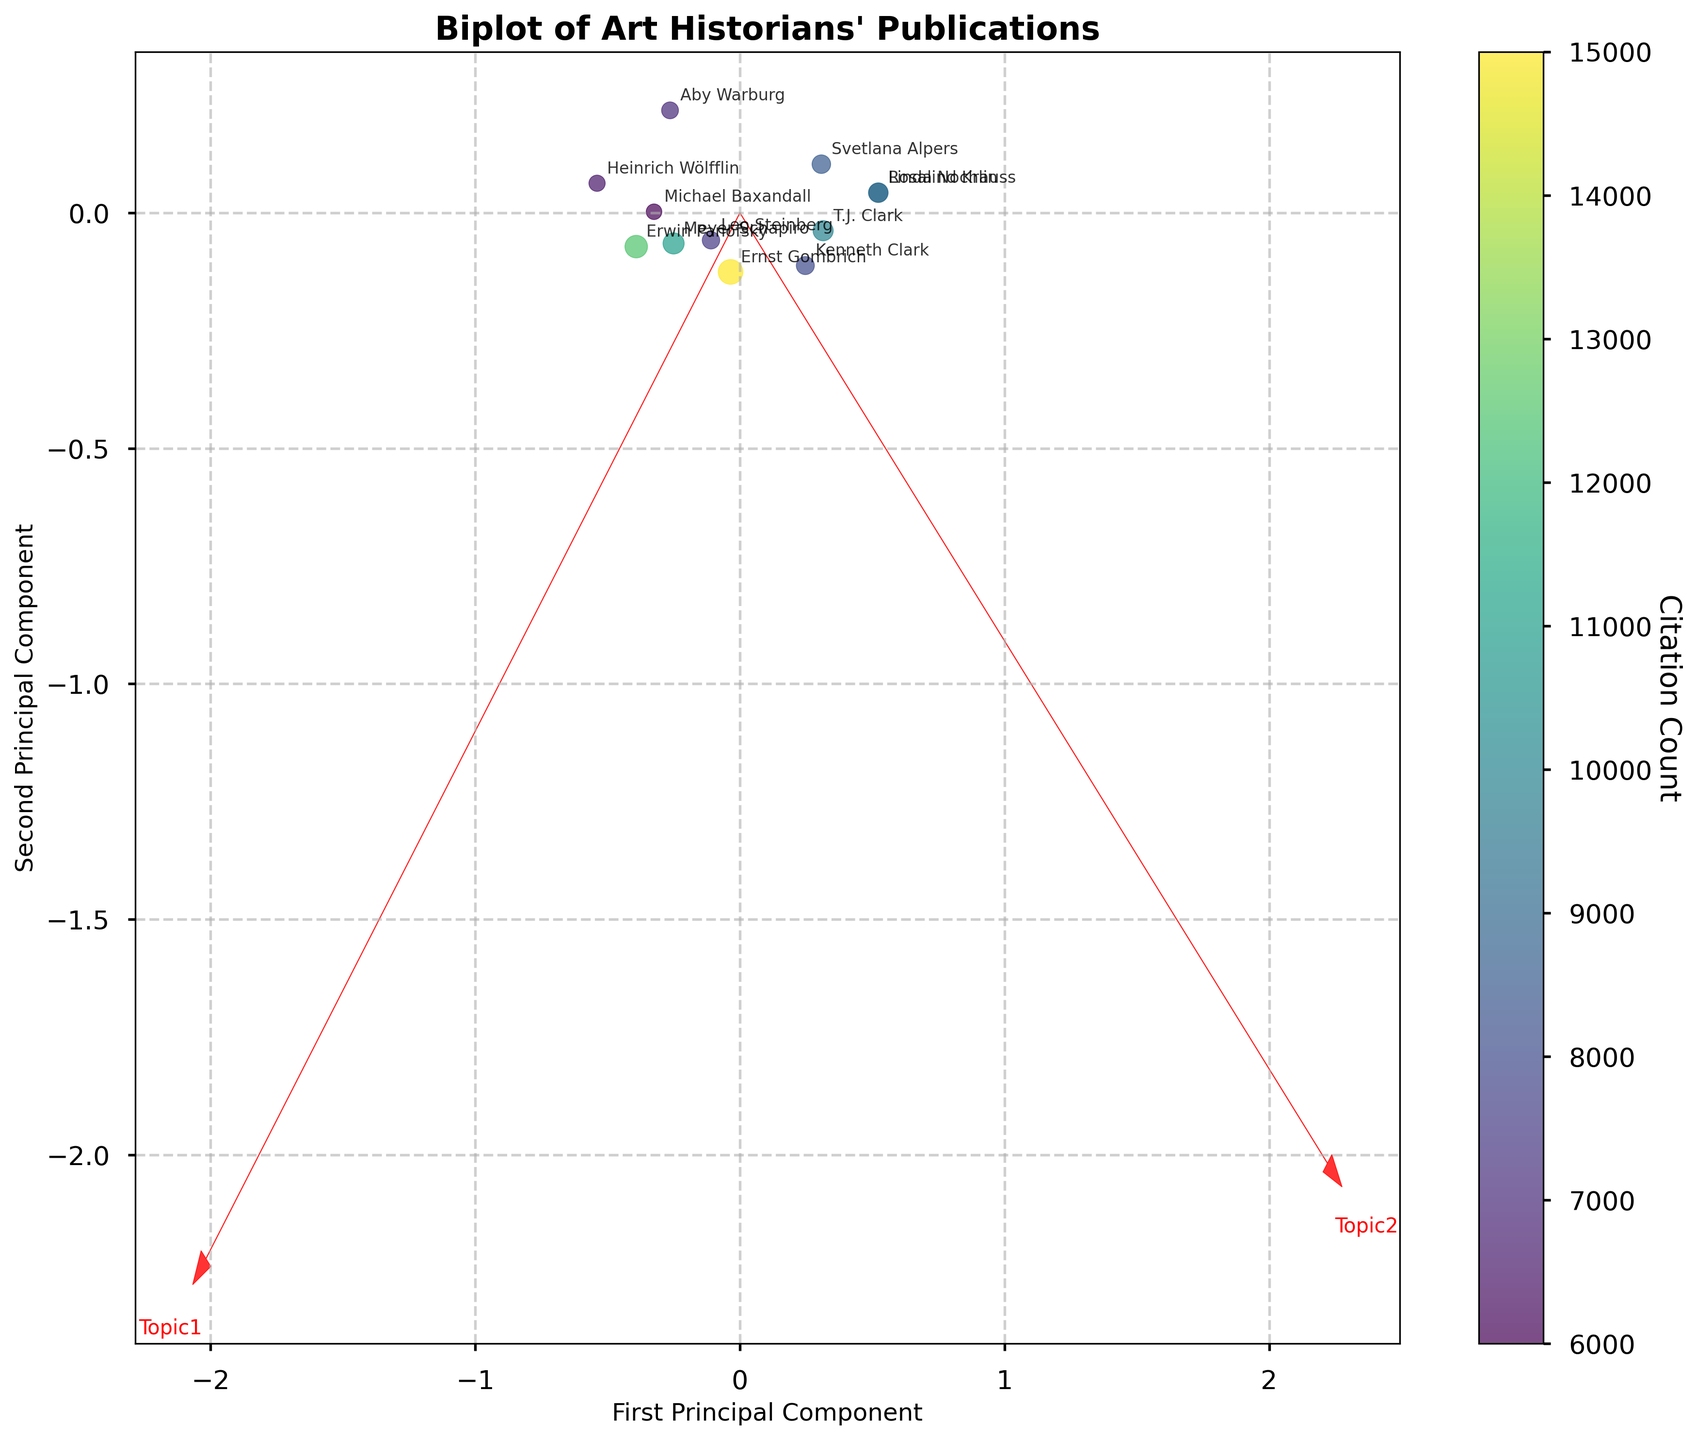What is the title of the figure? The title is usually shown at the top center of the figure. In this case, it reads "Biplot of Art Historians' Publications".
Answer: Biplot of Art Historians' Publications Which axes are used in the plot, and what do they represent? The x-axis represents the "First Principal Component" and the y-axis represents the "Second Principal Component", as indicated by the labels on the figure.
Answer: First Principal Component, Second Principal Component How are the citation counts represented in the figure? The citation counts are represented by the size and color of the data points. Larger points with color towards the purple end of the spectrum indicate a higher citation count.
Answer: By the size and color of the points Which two vectors are plotted in the figure, and what do they represent? The vectors plotted are "Topic1" and "Topic2", indicated by red arrows. These represent the variable vectors in the principal component space.
Answer: Topic1 and Topic2 Which art historian has the highest citation count, and how can you tell? The art historian with the highest citation count is Ernst Gombrich, as indicated by the largest and darkest (purple) data point in the figure.
Answer: Ernst Gombrich What are the positions of Erwin Panofsky and Linda Nochlin in the plot relative to each other? Erwin Panofsky is positioned on the left side of the plot, while Linda Nochlin is in the upper central area, meaning Panofsky is to the left and below Nochlin.
Answer: Panofsky is to the left and below Nochlin Which vectors point closest to the direction of the first principal component axis? The vector for "Topic1" points closest to the direction of the first principal component axis, given that it has a significant component along this axis.
Answer: Topic1 Which art historians are most aligned with Topic2 based on their positions in the plot? Linda Nochlin, T.J. Clark, and Rosalind Krauss are most aligned with Topic2, as they are positioned in the same direction as the Topic2 vector.
Answer: Linda Nochlin, T.J. Clark, and Rosalind Krauss What is the relative magnitude of the components for Topic1 and Topic2 vectors on the first principal component? The relative magnitude can be seen by the length of the arrows on the x-axis. The Topic1 vector has a larger first component than the Topic2 vector, as indicated by its longer projection along that axis.
Answer: Topic1 > Topic2 